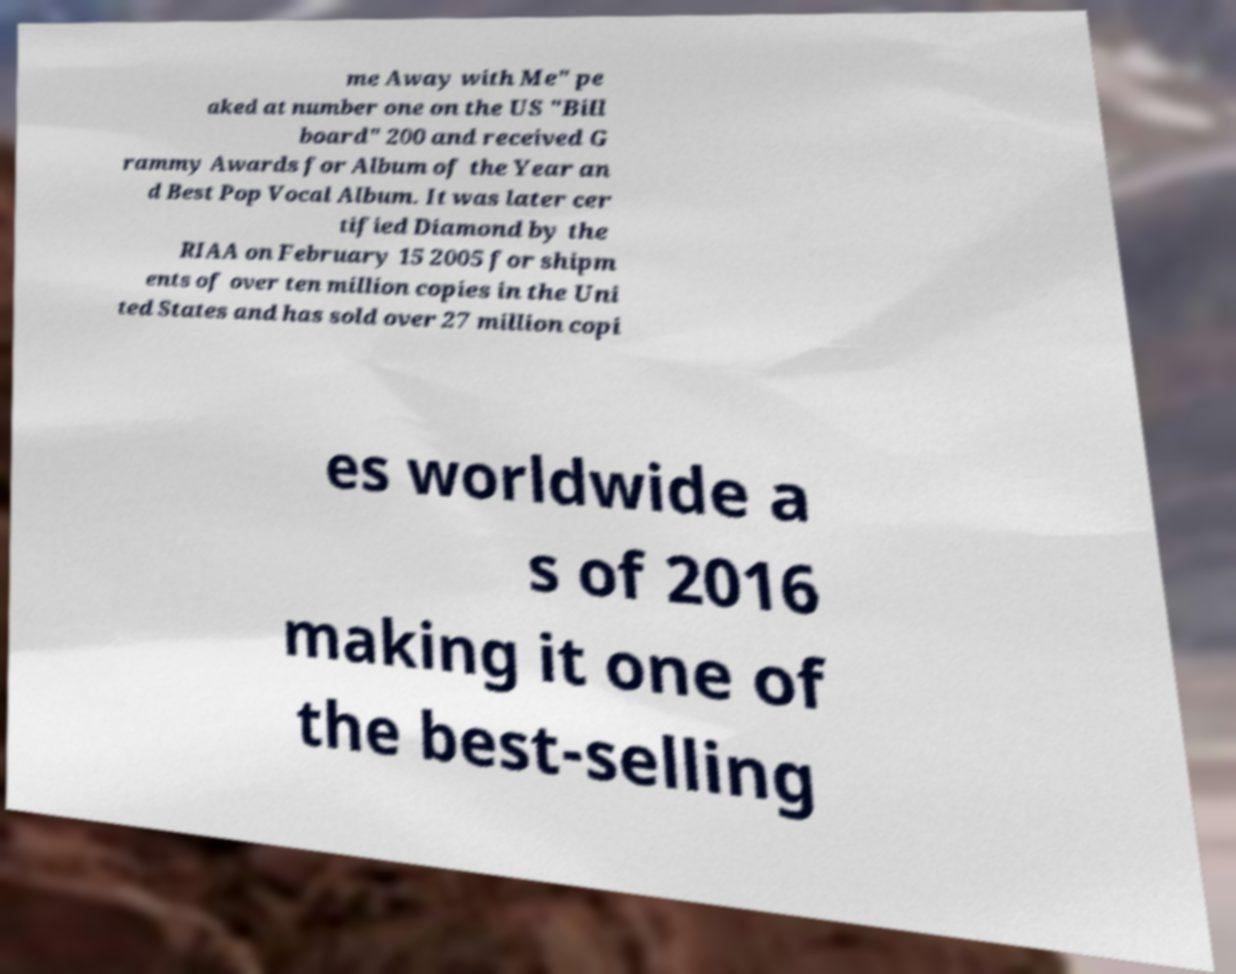Could you extract and type out the text from this image? me Away with Me" pe aked at number one on the US "Bill board" 200 and received G rammy Awards for Album of the Year an d Best Pop Vocal Album. It was later cer tified Diamond by the RIAA on February 15 2005 for shipm ents of over ten million copies in the Uni ted States and has sold over 27 million copi es worldwide a s of 2016 making it one of the best-selling 